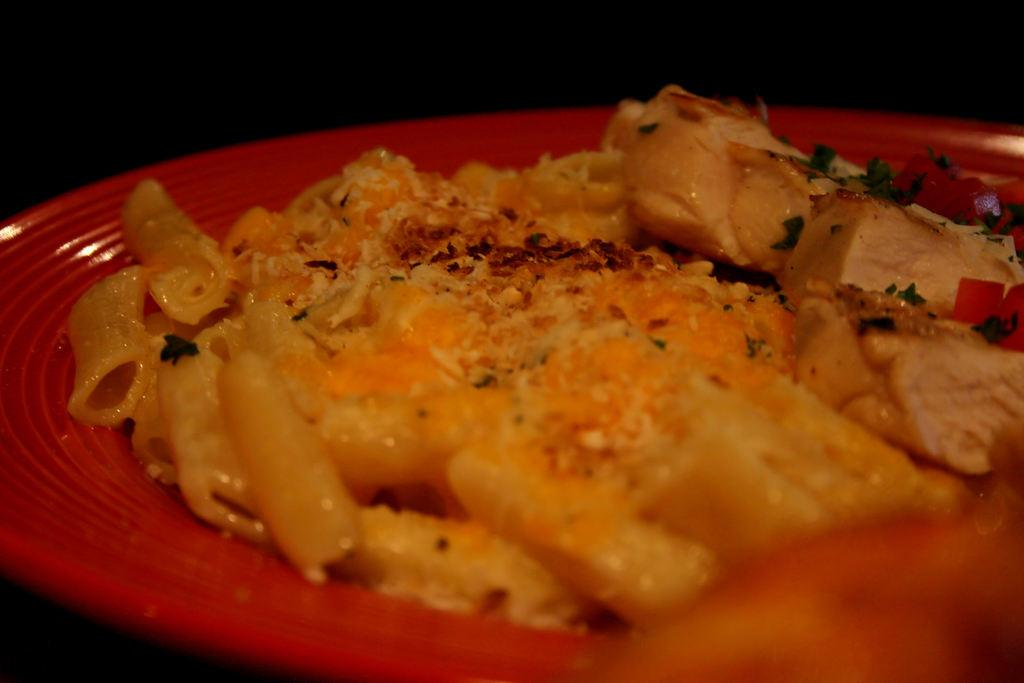What object is present in the image that is typically used for serving food? There is a plate in the image. What color is the plate? The plate is red in color. What is on the plate? There is food on the plate. What color is the background of the plate? The background of the plate is blue. What type of decision is being made by the plate in the image? There is no indication in the image that the plate is making any decisions. 